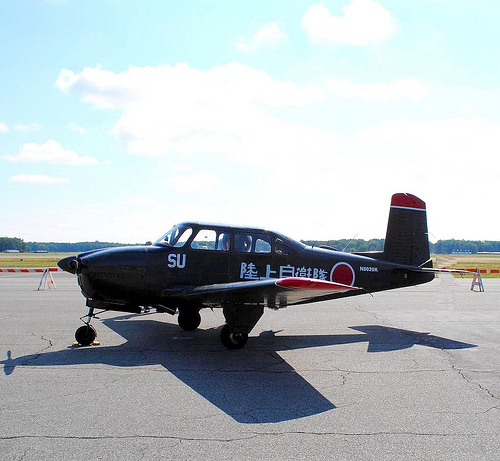Please provide the bounding box coordinate of the region this sentence describes: the back wheel of a plane. The back wheel of the plane is located within the bounding box coordinates [0.35, 0.66, 0.4, 0.7], important for supporting the aircraft during landing and takeoff. 